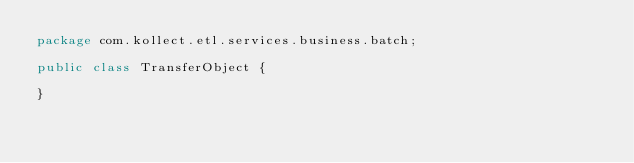<code> <loc_0><loc_0><loc_500><loc_500><_Java_>package com.kollect.etl.services.business.batch;

public class TransferObject {

}
</code> 